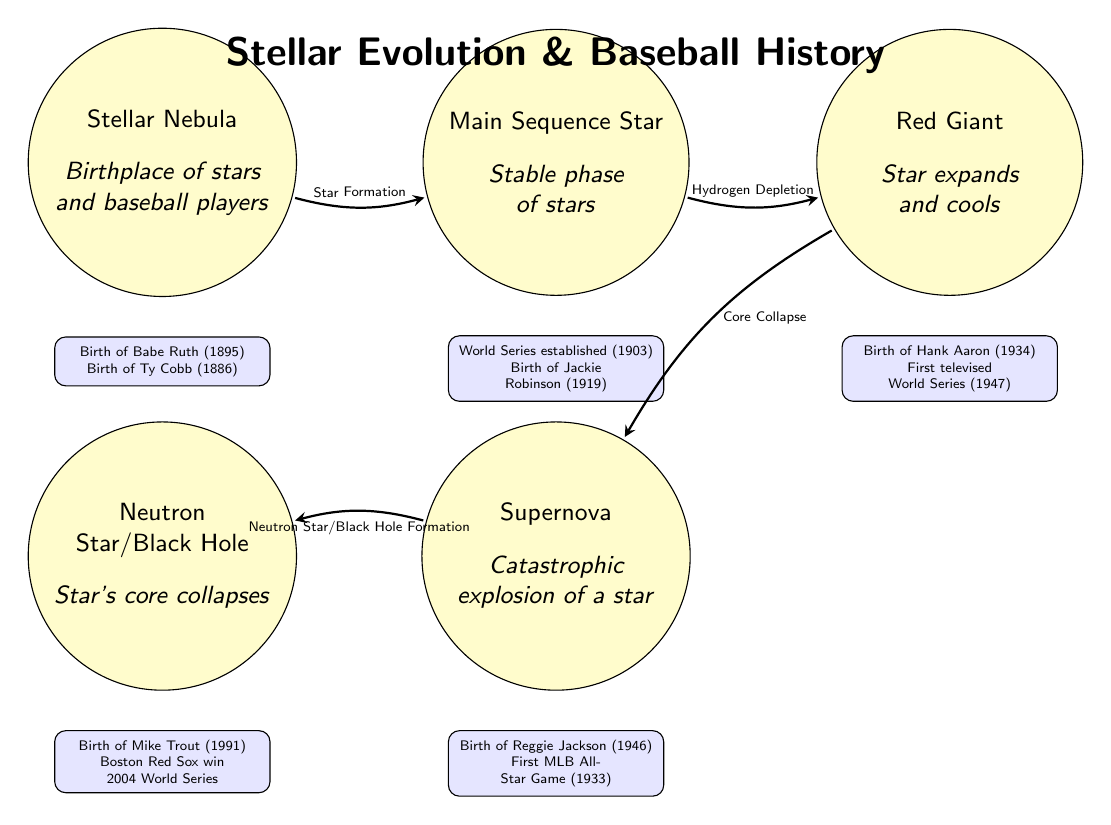What is the birth year of Babe Ruth? The diagram indicates that Babe Ruth was born in 1895, which is listed under the event box associated with the Stellar Nebula stage.
Answer: 1895 What event is noted during the Red Giant phase? The diagram shows that the Red Giant stage includes the event "First televised World Series (1947)", found in the event box beneath the Red Giant node.
Answer: First televised World Series (1947) How many major events are listed in total in the diagram? The diagram has five event boxes, each containing two major events. Therefore, the total is 2 events per box multiplied by 5 boxes, which equals 10 events.
Answer: 10 Which player is associated with the Supernova stage? The diagram states that Reggie Jackson, born in 1946, is linked to the Supernova stage, as his birth year is shown in the event box beneath this node.
Answer: Reggie Jackson What transition leads to the Neutron Star/Black Hole phase? The diagram specifies that the transition leading to the Neutron Star/Black Hole phase is called "Neutron Star/Black Hole Formation," which connects from the Supernova node.
Answer: Neutron Star/Black Hole Formation Which year saw the establishment of the World Series? According to the main sequence event box, the World Series was established in 1903, which is noted in the diagram.
Answer: 1903 Who is noted to have been born in 1991? The diagram indicates that Mike Trout was born in 1991, which is displayed in the event box associated with the Neutron Star/Black Hole phase.
Answer: Mike Trout What is the progression of star stages from the Nebula to the Neutron Star/Black Hole? The diagram illustrates a clear progression: Stellar Nebula to Main Sequence Star, then to Red Giant, followed by Supernova, and finally Neutron Star/Black Hole. This shows the transformational stages of a star’s life cycle.
Answer: Stellar Nebula → Main Sequence Star → Red Giant → Supernova → Neutron Star/Black Hole 